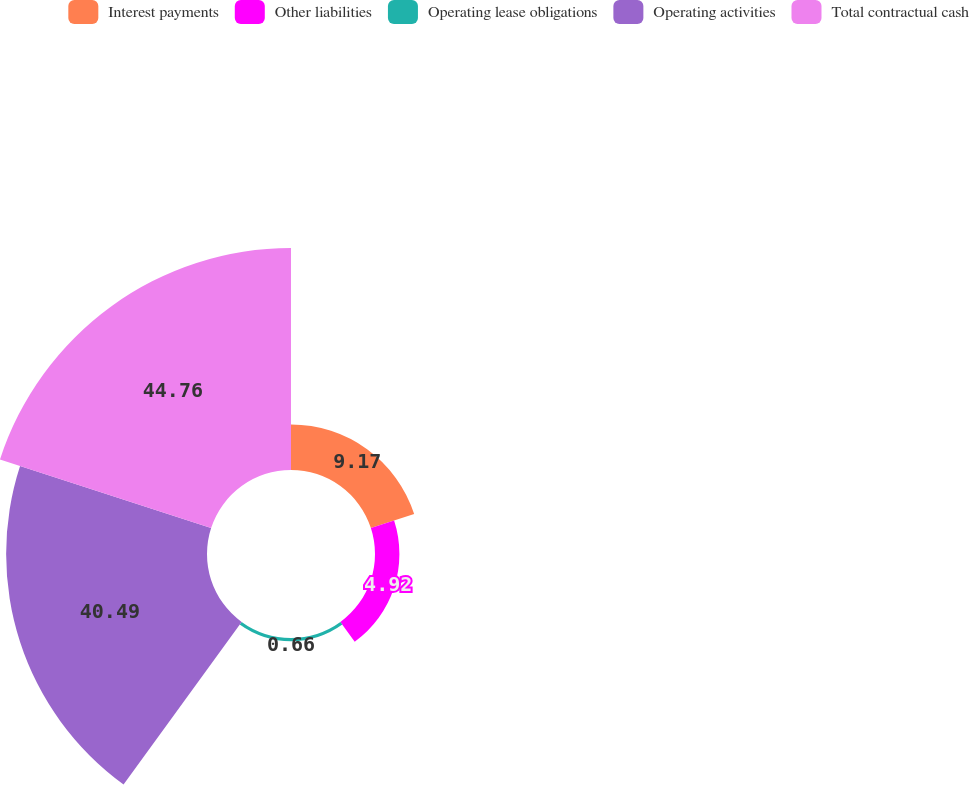Convert chart to OTSL. <chart><loc_0><loc_0><loc_500><loc_500><pie_chart><fcel>Interest payments<fcel>Other liabilities<fcel>Operating lease obligations<fcel>Operating activities<fcel>Total contractual cash<nl><fcel>9.17%<fcel>4.92%<fcel>0.66%<fcel>40.49%<fcel>44.75%<nl></chart> 